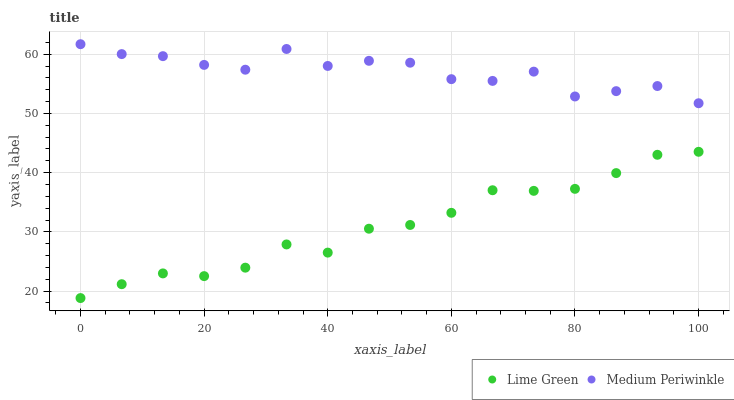Does Lime Green have the minimum area under the curve?
Answer yes or no. Yes. Does Medium Periwinkle have the maximum area under the curve?
Answer yes or no. Yes. Does Lime Green have the maximum area under the curve?
Answer yes or no. No. Is Lime Green the smoothest?
Answer yes or no. Yes. Is Medium Periwinkle the roughest?
Answer yes or no. Yes. Is Lime Green the roughest?
Answer yes or no. No. Does Lime Green have the lowest value?
Answer yes or no. Yes. Does Medium Periwinkle have the highest value?
Answer yes or no. Yes. Does Lime Green have the highest value?
Answer yes or no. No. Is Lime Green less than Medium Periwinkle?
Answer yes or no. Yes. Is Medium Periwinkle greater than Lime Green?
Answer yes or no. Yes. Does Lime Green intersect Medium Periwinkle?
Answer yes or no. No. 